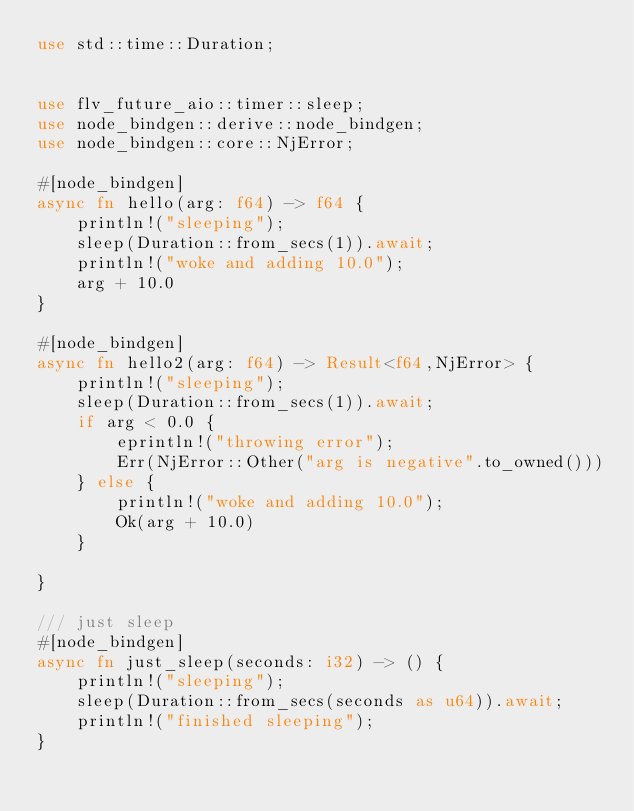<code> <loc_0><loc_0><loc_500><loc_500><_Rust_>use std::time::Duration;


use flv_future_aio::timer::sleep;
use node_bindgen::derive::node_bindgen;
use node_bindgen::core::NjError;

#[node_bindgen]
async fn hello(arg: f64) -> f64 {
    println!("sleeping");
    sleep(Duration::from_secs(1)).await;
    println!("woke and adding 10.0");
    arg + 10.0
}

#[node_bindgen]
async fn hello2(arg: f64) -> Result<f64,NjError> {
    println!("sleeping");
    sleep(Duration::from_secs(1)).await;
    if arg < 0.0 {
        eprintln!("throwing error");
        Err(NjError::Other("arg is negative".to_owned()))
    } else {
        println!("woke and adding 10.0");
        Ok(arg + 10.0)
    }
   
}

/// just sleep
#[node_bindgen]
async fn just_sleep(seconds: i32) -> () {
    println!("sleeping");
    sleep(Duration::from_secs(seconds as u64)).await;
    println!("finished sleeping");
}</code> 